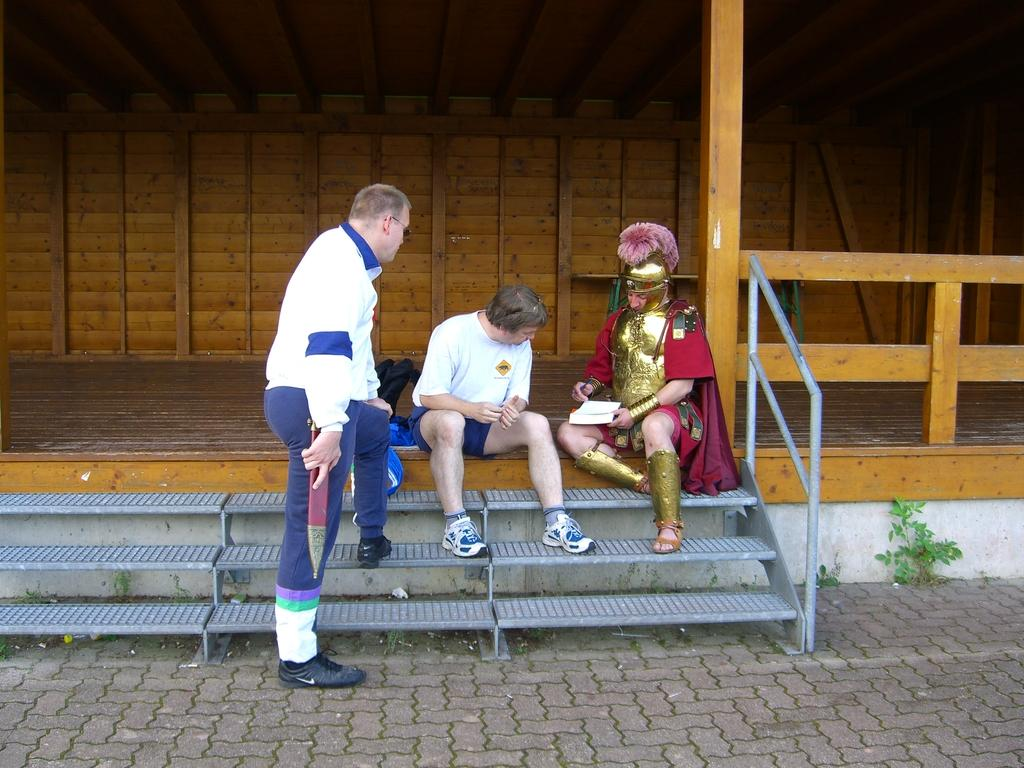How many people are in the image? There are three people in the image. What are the positions of the people in the image? One man is standing, while the others are sitting. What can be seen in the background of the image? There is a wooden wall in the background. Are there any architectural features in the image? Yes, there are steps in the image. What else can be seen in the image? There is a fence and plants in the image. What is the rate at which the sheet of flesh is growing in the image? There is no sheet of flesh present in the image, so it is not possible to determine a growth rate. 